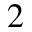<formula> <loc_0><loc_0><loc_500><loc_500>2</formula> 